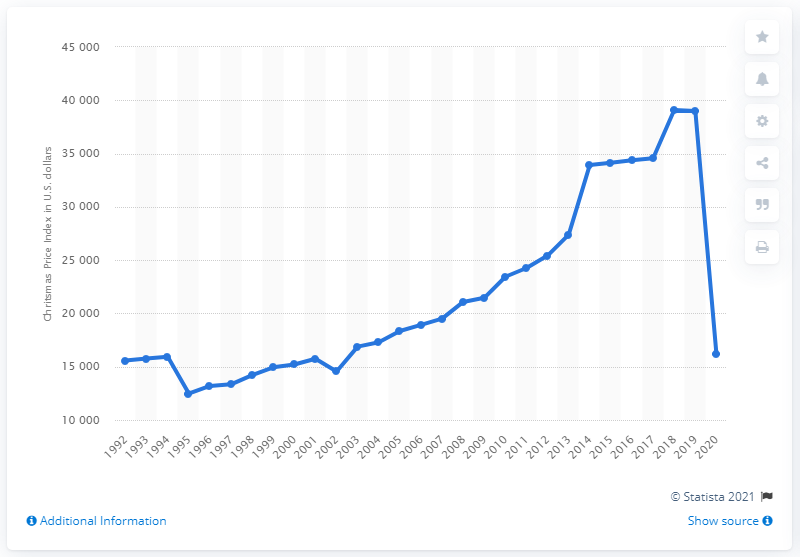Point out several critical features in this image. In the United States, the PNC Christmas Price Index was valued at 159,442.2 dollars in 1994. In the year 2020, the PNC Christmas Price Index decreased. 